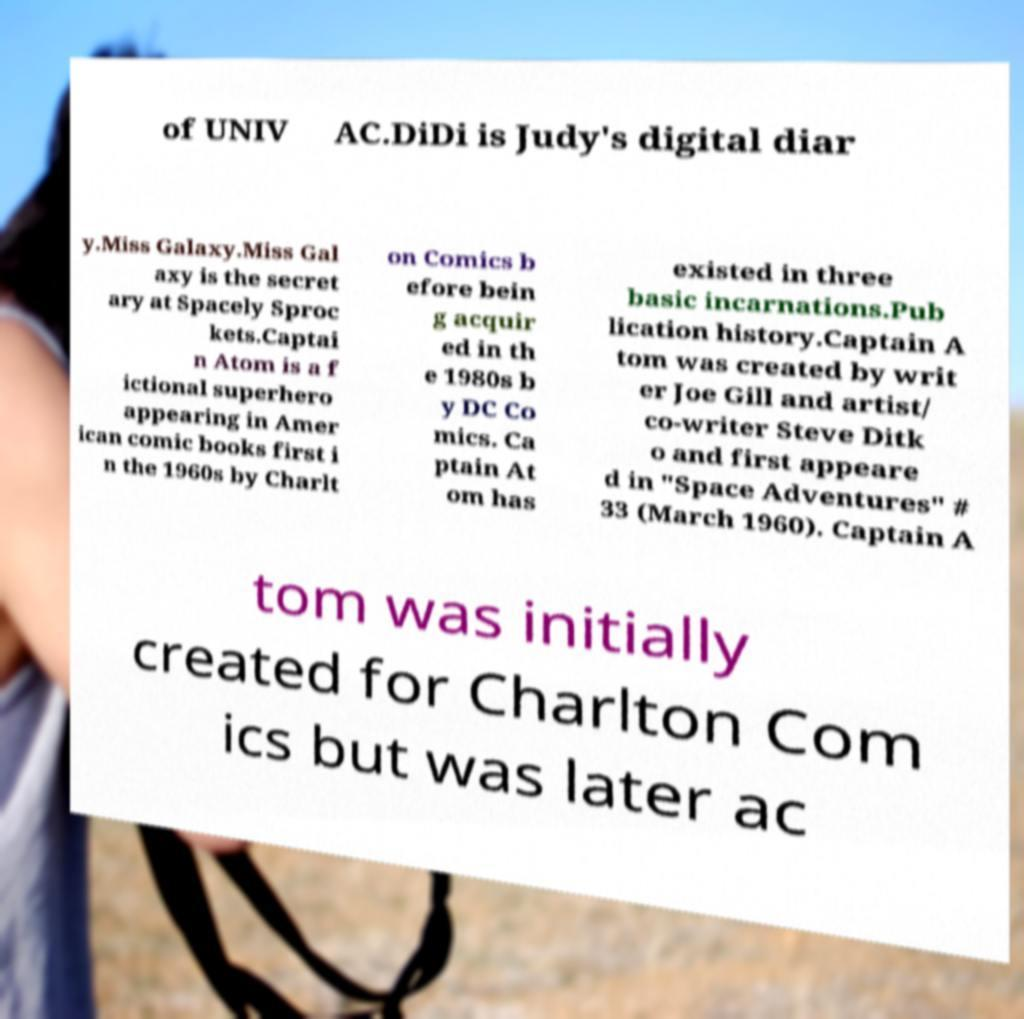For documentation purposes, I need the text within this image transcribed. Could you provide that? of UNIV AC.DiDi is Judy's digital diar y.Miss Galaxy.Miss Gal axy is the secret ary at Spacely Sproc kets.Captai n Atom is a f ictional superhero appearing in Amer ican comic books first i n the 1960s by Charlt on Comics b efore bein g acquir ed in th e 1980s b y DC Co mics. Ca ptain At om has existed in three basic incarnations.Pub lication history.Captain A tom was created by writ er Joe Gill and artist/ co-writer Steve Ditk o and first appeare d in "Space Adventures" # 33 (March 1960). Captain A tom was initially created for Charlton Com ics but was later ac 